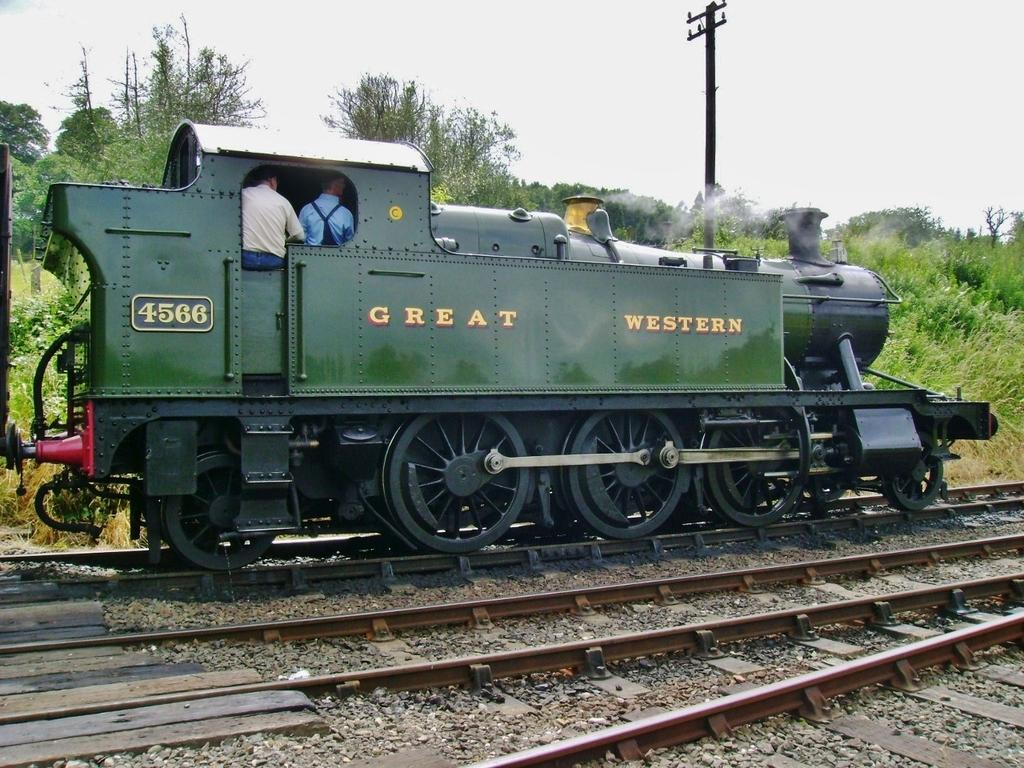What is the main subject of the image? The main subject of the image is a train. What can be observed about the train's position in the image? The train is on a track. How many people are inside the train? There are two persons inside the train. What can be seen behind the train? Plants and electric poles are visible behind the train. What is visible above the train? The sky is visible above the train. Can you see a tiger walking behind the train? There is no tiger visible in the image. 